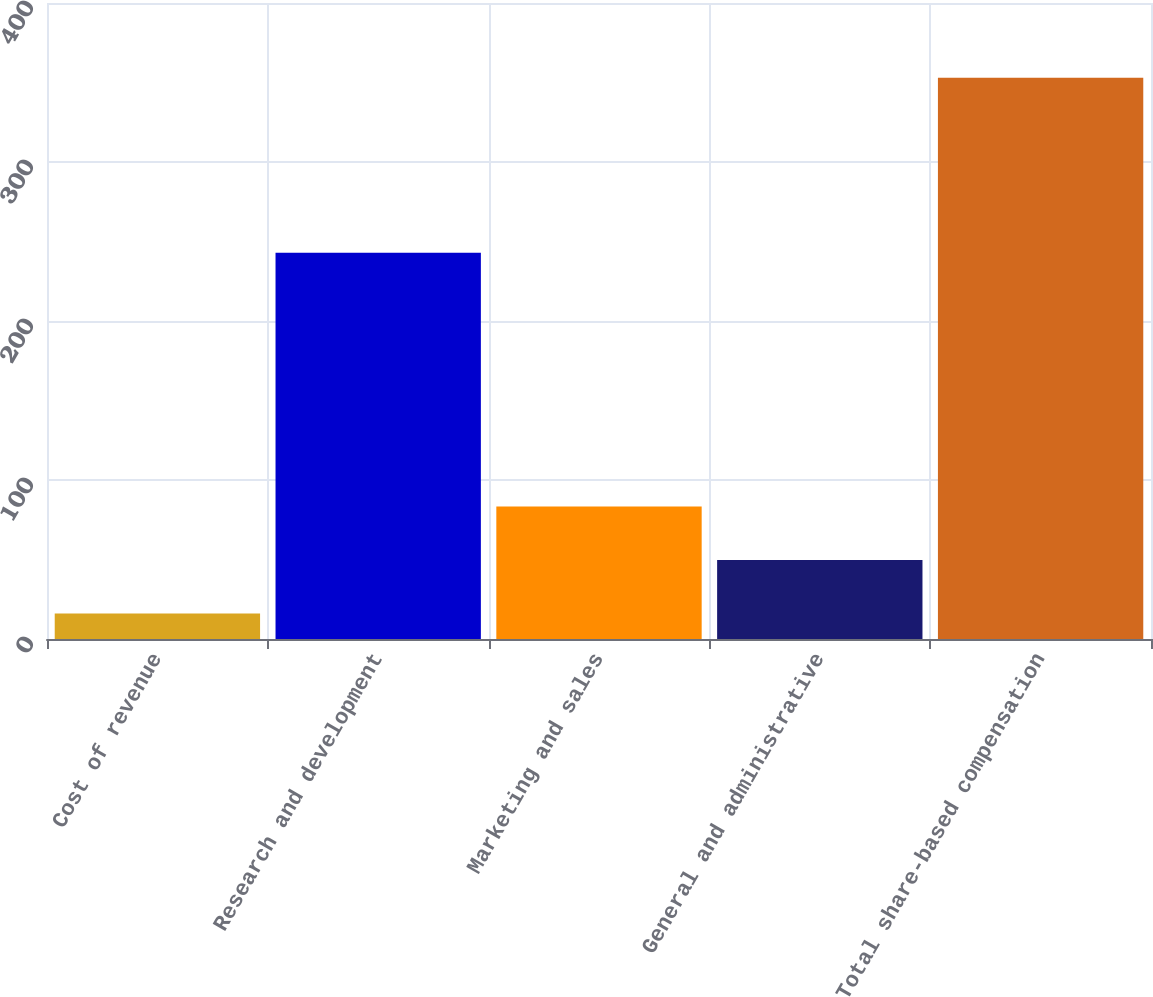<chart> <loc_0><loc_0><loc_500><loc_500><bar_chart><fcel>Cost of revenue<fcel>Research and development<fcel>Marketing and sales<fcel>General and administrative<fcel>Total share-based compensation<nl><fcel>16<fcel>243<fcel>83.4<fcel>49.7<fcel>353<nl></chart> 